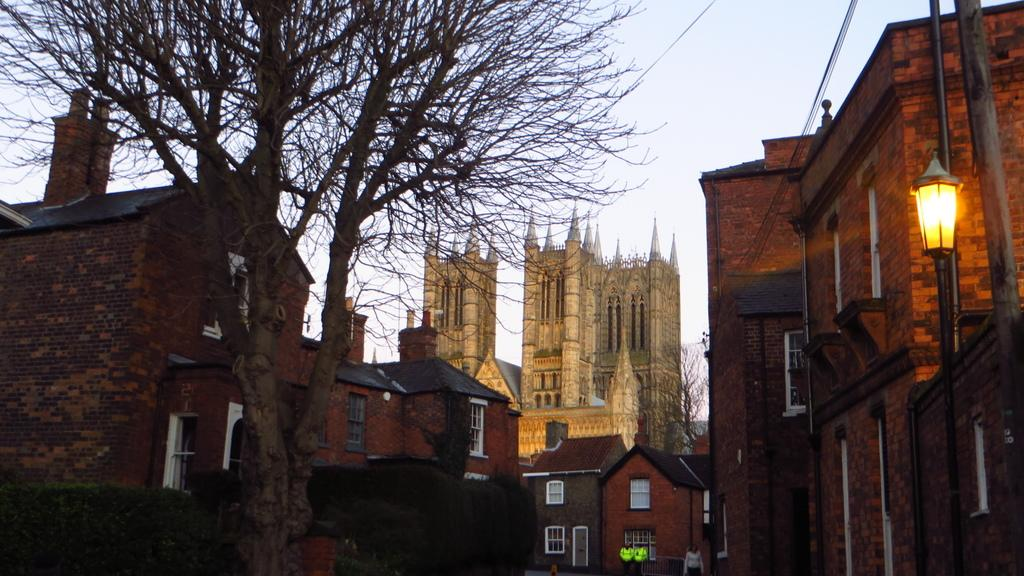What type of structures can be seen in the image? There are buildings in the image. What is located in the middle of the image? There is a tree in the middle of the image. Where is the light coming from in the image? The light is coming from the right side of the image. What can be seen in the background of the image? There is a sky visible in the background of the image. How many slaves are visible in the image? There are no slaves present in the image. What type of horses can be seen in the image? There are no horses present in the image. 